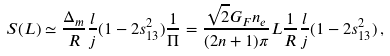Convert formula to latex. <formula><loc_0><loc_0><loc_500><loc_500>S ( L ) & \simeq \frac { \Delta _ { m } } { R } \frac { l } { j } ( 1 - 2 s _ { 1 3 } ^ { 2 } ) \frac { 1 } { \Pi } = \frac { \sqrt { 2 } G _ { F } n _ { e } } { ( 2 n + 1 ) \pi } L \frac { 1 } { R } \frac { l } { j } ( 1 - 2 s _ { 1 3 } ^ { 2 } ) \, ,</formula> 